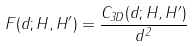Convert formula to latex. <formula><loc_0><loc_0><loc_500><loc_500>F ( d ; H , H ^ { \prime } ) = \frac { C _ { 3 D } ( d ; H , H ^ { \prime } ) } { d ^ { 2 } }</formula> 